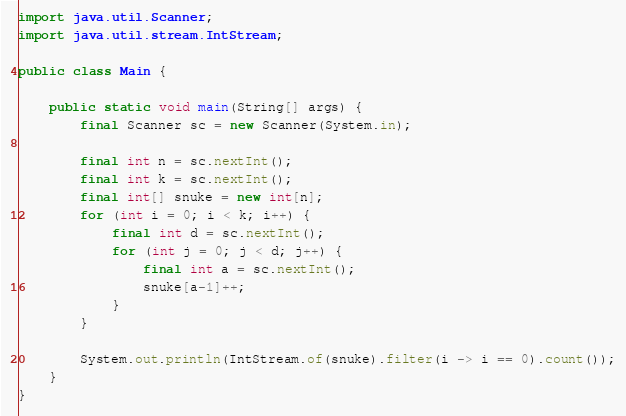<code> <loc_0><loc_0><loc_500><loc_500><_Java_>import java.util.Scanner;
import java.util.stream.IntStream;

public class Main {

    public static void main(String[] args) {
        final Scanner sc = new Scanner(System.in);

        final int n = sc.nextInt();
        final int k = sc.nextInt();
        final int[] snuke = new int[n];
        for (int i = 0; i < k; i++) {
            final int d = sc.nextInt();
            for (int j = 0; j < d; j++) {
                final int a = sc.nextInt();
                snuke[a-1]++;
            }
        }

        System.out.println(IntStream.of(snuke).filter(i -> i == 0).count());
    }
}
</code> 